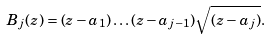<formula> <loc_0><loc_0><loc_500><loc_500>B _ { j } ( z ) = ( z - a _ { 1 } ) \dots ( z - a _ { j - 1 } ) \sqrt { ( z - a _ { j } ) } .</formula> 